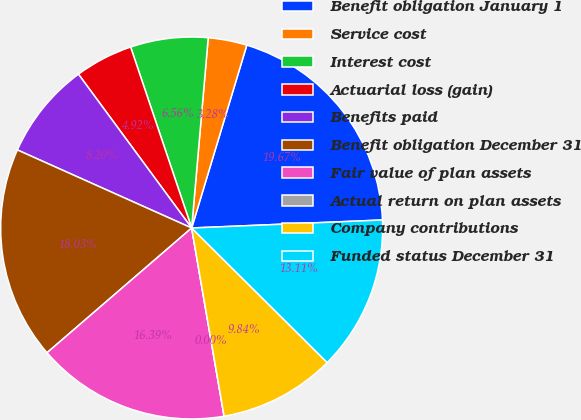Convert chart to OTSL. <chart><loc_0><loc_0><loc_500><loc_500><pie_chart><fcel>Benefit obligation January 1<fcel>Service cost<fcel>Interest cost<fcel>Actuarial loss (gain)<fcel>Benefits paid<fcel>Benefit obligation December 31<fcel>Fair value of plan assets<fcel>Actual return on plan assets<fcel>Company contributions<fcel>Funded status December 31<nl><fcel>19.67%<fcel>3.28%<fcel>6.56%<fcel>4.92%<fcel>8.2%<fcel>18.03%<fcel>16.39%<fcel>0.0%<fcel>9.84%<fcel>13.11%<nl></chart> 